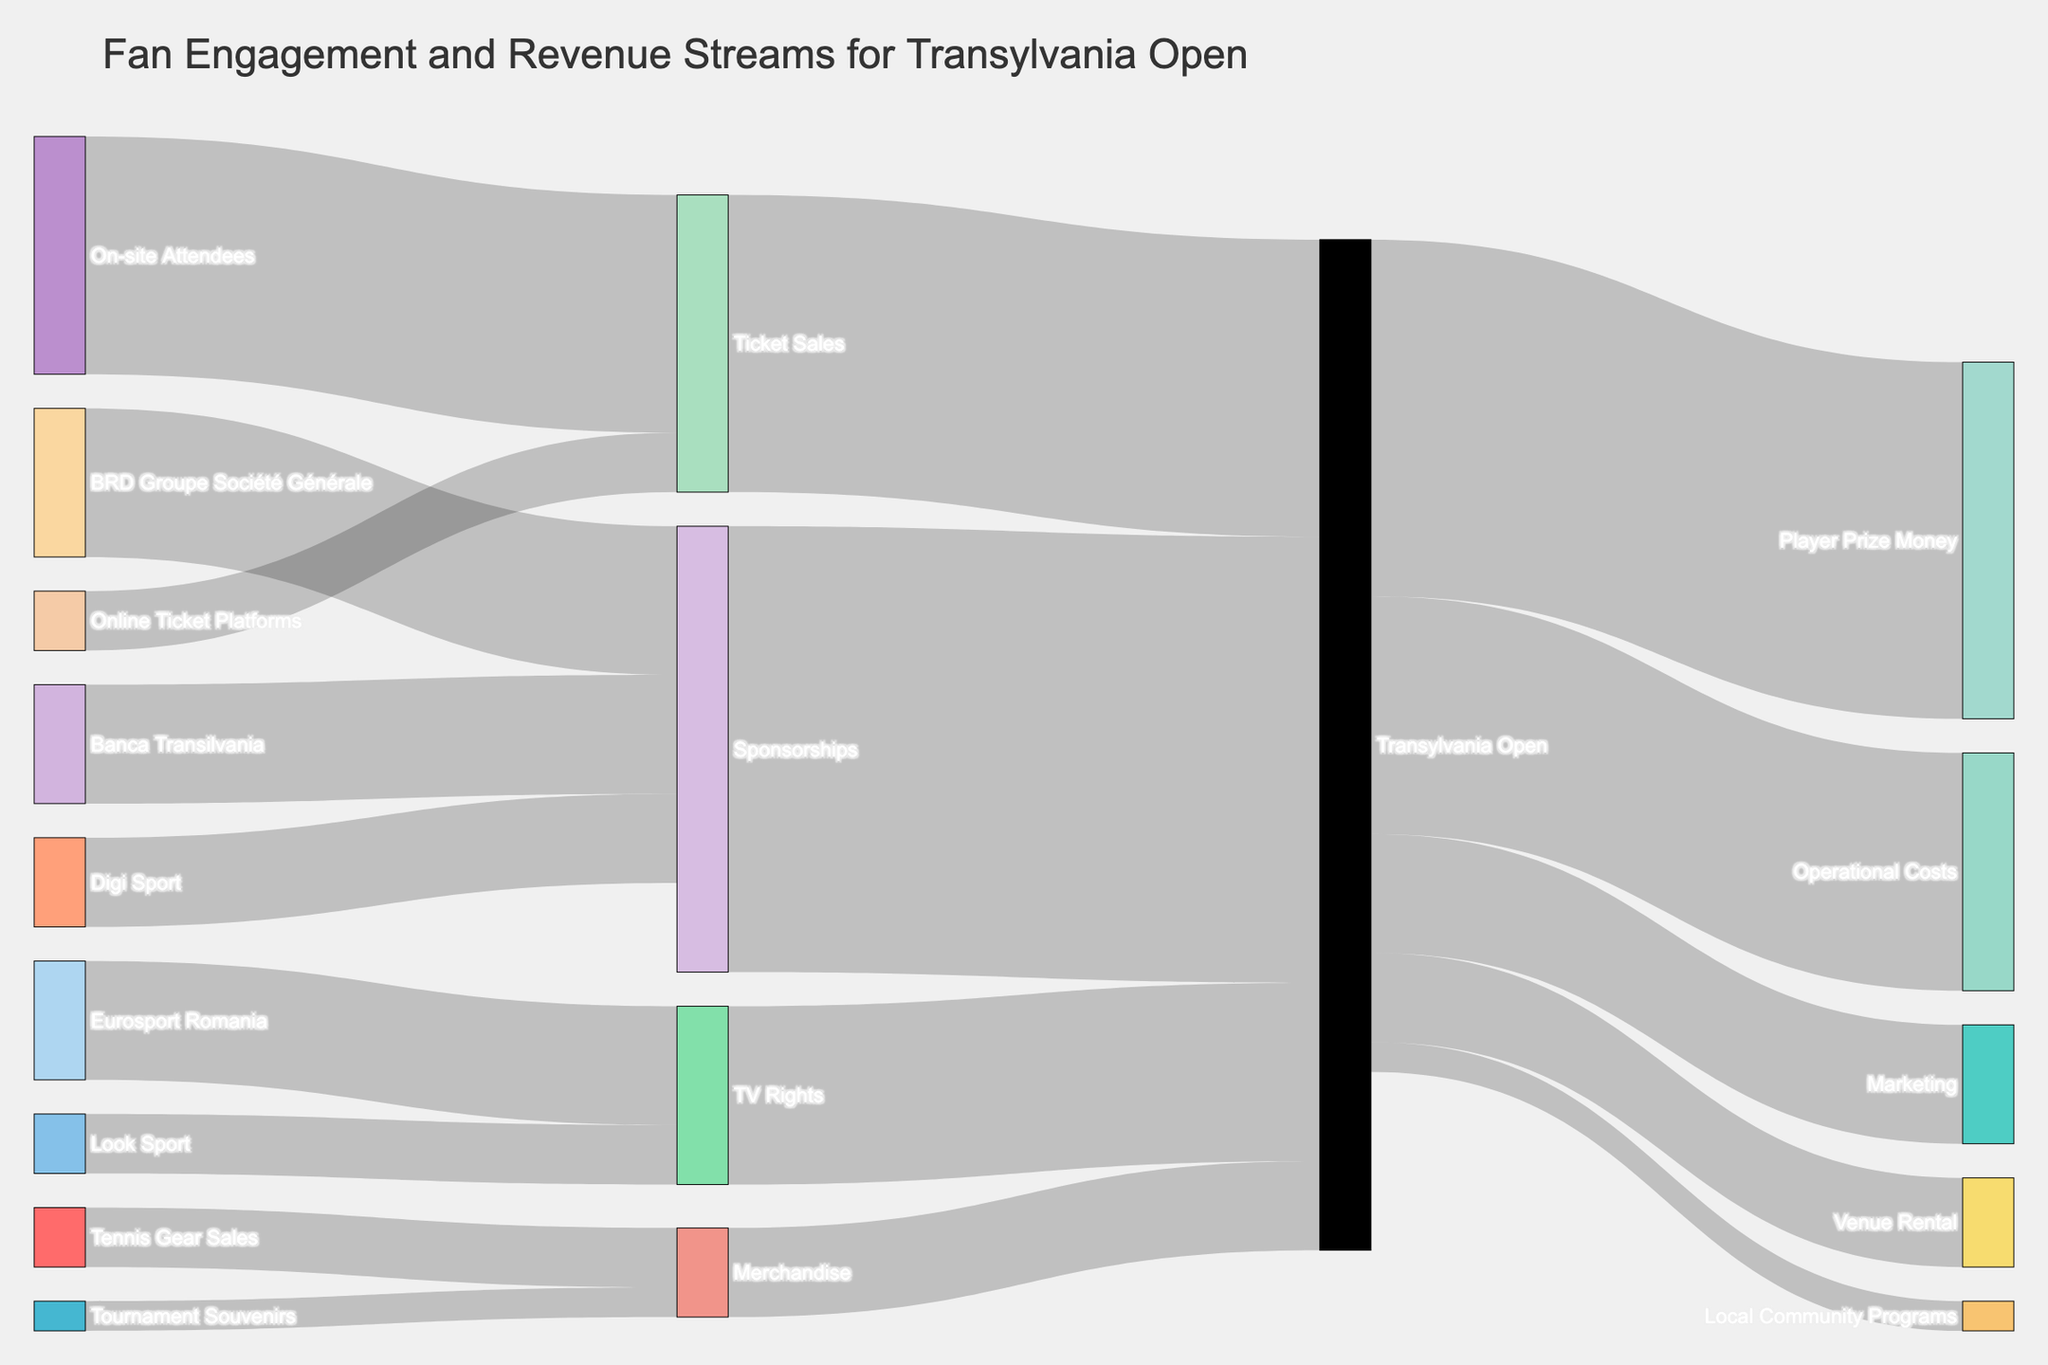what are the main revenue streams for the Transylvania Open? The main revenue streams are represented by the largest incoming flows into the "Transylvania Open" node on the Sankey diagram. These are Ticket Sales, Sponsorships, TV Rights, and Merchandise.
Answer: Ticket Sales, Sponsorships, TV Rights, Merchandise Which revenue stream contributes the most to the Transylvania Open? By observing the thickness of the flows and the values at the start, Sponsorships have the largest value, indicating the highest contribution.
Answer: Sponsorships How much total revenue does the Transylvania Open generate from Ticket Sales? Sum the values from "On-site Attendees" to "Ticket Sales" and from "Online Ticket Platforms" to "Ticket Sales", which is 400,000 + 100,000.
Answer: 500,000 What are the main expenses of the Transylvania Open and their respective values? Look at the outgoing flows from the "Transylvania Open" node to identify its expenses: Player Prize Money (600,000), Operational Costs (400,000), Marketing (200,000), Venue Rental (150,000), and Local Community Programs (50,000).
Answer: Player Prize Money 600,000, Operational Costs 400,000, Marketing 200,000, Venue Rental 150,000, Local Community Programs 50,000 What is the difference between the revenue generated from Ticket Sales and TV Rights for the Transylvania Open? Subtract the value of TV Rights from Ticket Sales: 500,000 - 300,000.
Answer: 200,000 Which sponsorship sources contribute to the total Sponsorship amount? Identify the sources connected to the "Sponsorships" node: BRD Groupe Société Générale, Banca Transilvania, and Digi Sport.
Answer: BRD Groupe Société Générale, Banca Transilvania, Digi Sport How much money is allocated to Local Community Programs from the Transylvania Open's total revenue? Look for the flow from "Transylvania Open" to "Local Community Programs".
Answer: 50,000 How does the revenue from Merchandise break down by its sources? Look at the flows going into "Merchandise": Tennis Gear Sales (100,000) and Tournament Souvenirs (50,000).
Answer: Tennis Gear Sales 100,000, Tournament Souvenirs 50,000 Which TV networks contribute to the revenue from TV Rights and by how much each? Identify the "TV Rights" node and trace the incoming flows to find Eurosport Romania (200,000) and Look Sport (100,000).
Answer: Eurosport Romania 200,000, Look Sport 100,000 What is the total amount of sponsorships received by the Transylvania Open? Sum the values from "BRD Groupe Société Générale," "Banca Transilvania," and "Digi Sport" to "Sponsorships," which is 250,000 + 200,000 + 150,000.
Answer: 600,000 